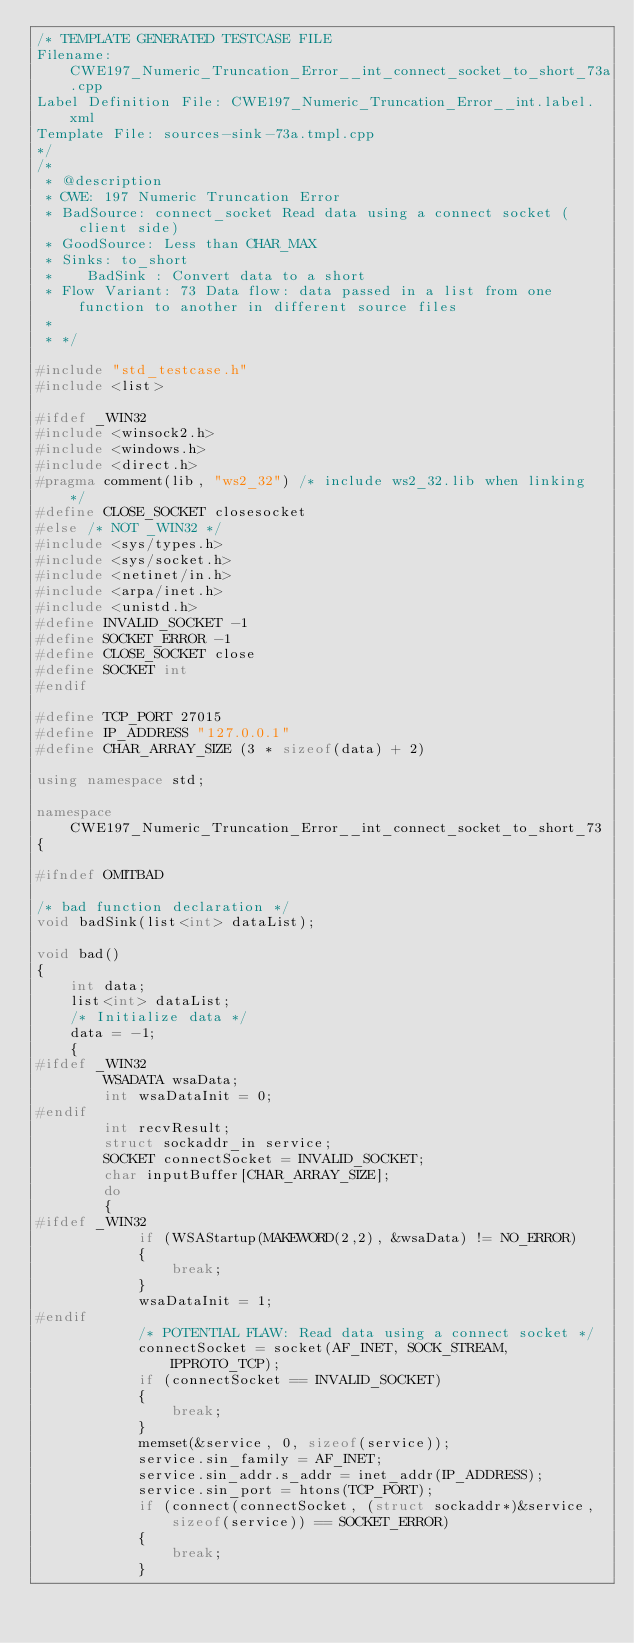<code> <loc_0><loc_0><loc_500><loc_500><_C++_>/* TEMPLATE GENERATED TESTCASE FILE
Filename: CWE197_Numeric_Truncation_Error__int_connect_socket_to_short_73a.cpp
Label Definition File: CWE197_Numeric_Truncation_Error__int.label.xml
Template File: sources-sink-73a.tmpl.cpp
*/
/*
 * @description
 * CWE: 197 Numeric Truncation Error
 * BadSource: connect_socket Read data using a connect socket (client side)
 * GoodSource: Less than CHAR_MAX
 * Sinks: to_short
 *    BadSink : Convert data to a short
 * Flow Variant: 73 Data flow: data passed in a list from one function to another in different source files
 *
 * */

#include "std_testcase.h"
#include <list>

#ifdef _WIN32
#include <winsock2.h>
#include <windows.h>
#include <direct.h>
#pragma comment(lib, "ws2_32") /* include ws2_32.lib when linking */
#define CLOSE_SOCKET closesocket
#else /* NOT _WIN32 */
#include <sys/types.h>
#include <sys/socket.h>
#include <netinet/in.h>
#include <arpa/inet.h>
#include <unistd.h>
#define INVALID_SOCKET -1
#define SOCKET_ERROR -1
#define CLOSE_SOCKET close
#define SOCKET int
#endif

#define TCP_PORT 27015
#define IP_ADDRESS "127.0.0.1"
#define CHAR_ARRAY_SIZE (3 * sizeof(data) + 2)

using namespace std;

namespace CWE197_Numeric_Truncation_Error__int_connect_socket_to_short_73
{

#ifndef OMITBAD

/* bad function declaration */
void badSink(list<int> dataList);

void bad()
{
    int data;
    list<int> dataList;
    /* Initialize data */
    data = -1;
    {
#ifdef _WIN32
        WSADATA wsaData;
        int wsaDataInit = 0;
#endif
        int recvResult;
        struct sockaddr_in service;
        SOCKET connectSocket = INVALID_SOCKET;
        char inputBuffer[CHAR_ARRAY_SIZE];
        do
        {
#ifdef _WIN32
            if (WSAStartup(MAKEWORD(2,2), &wsaData) != NO_ERROR)
            {
                break;
            }
            wsaDataInit = 1;
#endif
            /* POTENTIAL FLAW: Read data using a connect socket */
            connectSocket = socket(AF_INET, SOCK_STREAM, IPPROTO_TCP);
            if (connectSocket == INVALID_SOCKET)
            {
                break;
            }
            memset(&service, 0, sizeof(service));
            service.sin_family = AF_INET;
            service.sin_addr.s_addr = inet_addr(IP_ADDRESS);
            service.sin_port = htons(TCP_PORT);
            if (connect(connectSocket, (struct sockaddr*)&service, sizeof(service)) == SOCKET_ERROR)
            {
                break;
            }</code> 